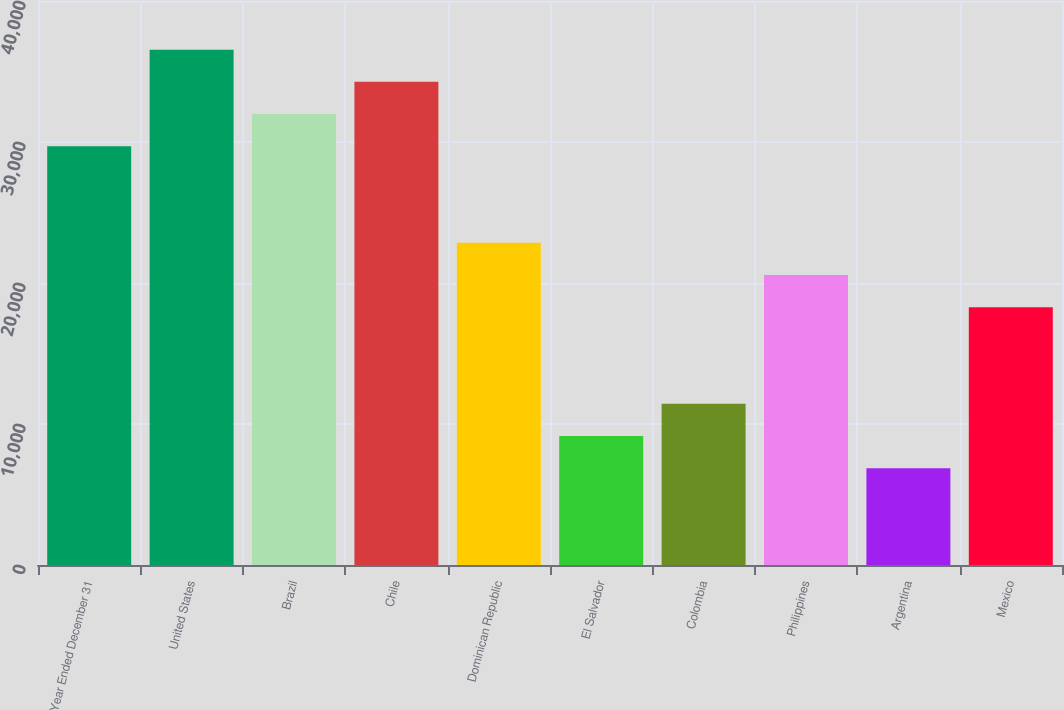Convert chart. <chart><loc_0><loc_0><loc_500><loc_500><bar_chart><fcel>Year Ended December 31<fcel>United States<fcel>Brazil<fcel>Chile<fcel>Dominican Republic<fcel>El Salvador<fcel>Colombia<fcel>Philippines<fcel>Argentina<fcel>Mexico<nl><fcel>29698.1<fcel>36549.2<fcel>31981.8<fcel>34265.5<fcel>22847<fcel>9144.8<fcel>11428.5<fcel>20563.3<fcel>6861.1<fcel>18279.6<nl></chart> 